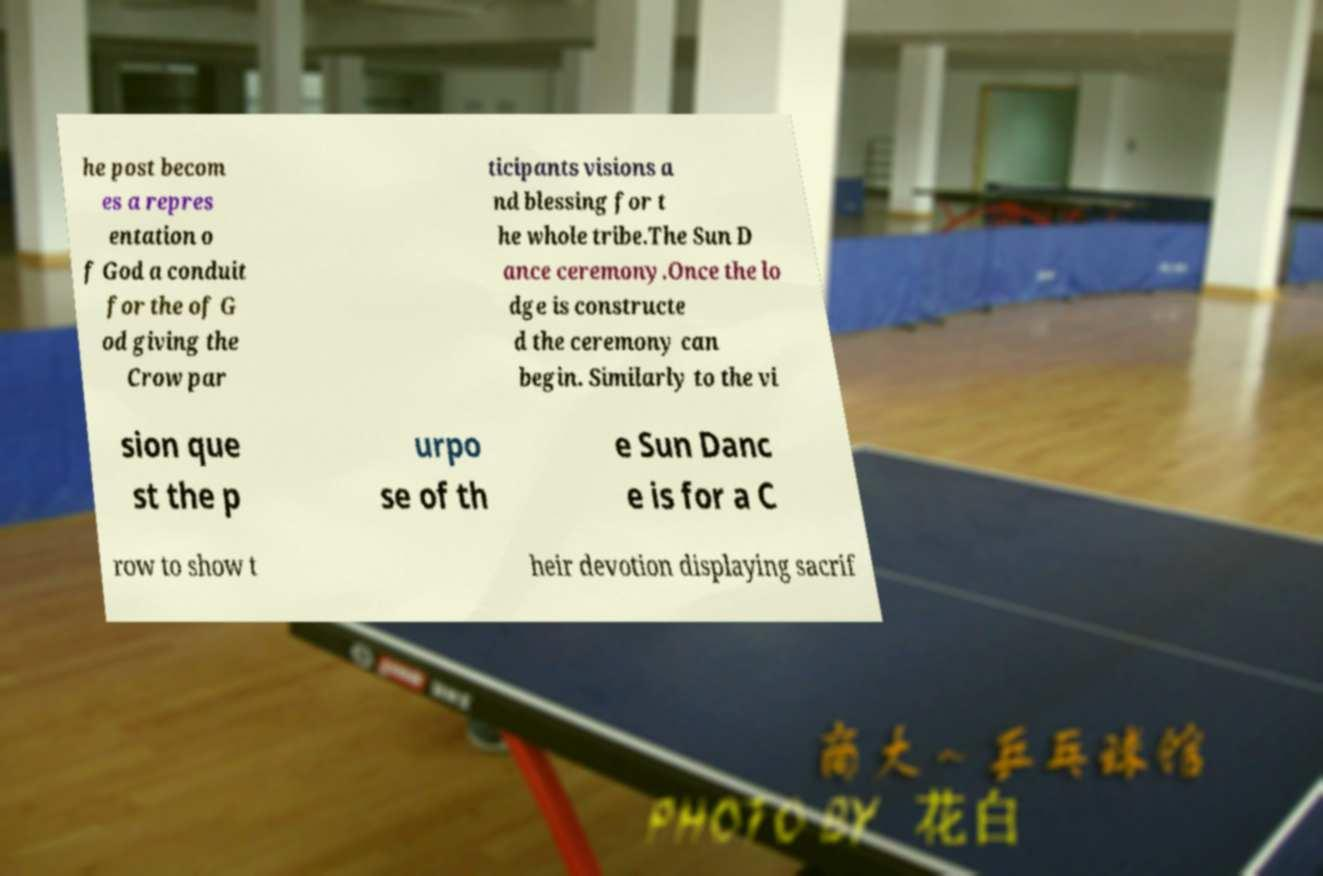For documentation purposes, I need the text within this image transcribed. Could you provide that? he post becom es a repres entation o f God a conduit for the of G od giving the Crow par ticipants visions a nd blessing for t he whole tribe.The Sun D ance ceremony.Once the lo dge is constructe d the ceremony can begin. Similarly to the vi sion que st the p urpo se of th e Sun Danc e is for a C row to show t heir devotion displaying sacrif 